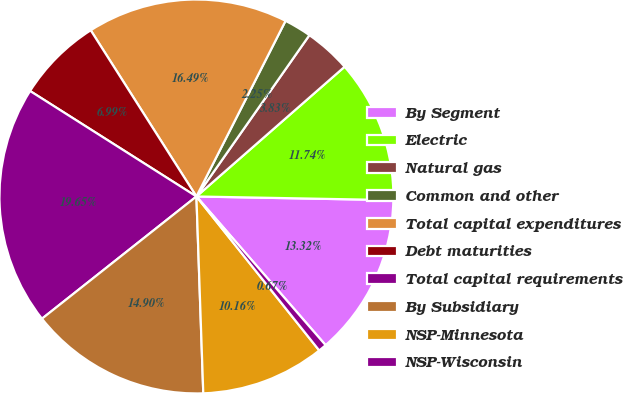Convert chart to OTSL. <chart><loc_0><loc_0><loc_500><loc_500><pie_chart><fcel>By Segment<fcel>Electric<fcel>Natural gas<fcel>Common and other<fcel>Total capital expenditures<fcel>Debt maturities<fcel>Total capital requirements<fcel>By Subsidiary<fcel>NSP-Minnesota<fcel>NSP-Wisconsin<nl><fcel>13.32%<fcel>11.74%<fcel>3.83%<fcel>2.25%<fcel>16.49%<fcel>6.99%<fcel>19.65%<fcel>14.9%<fcel>10.16%<fcel>0.67%<nl></chart> 